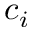<formula> <loc_0><loc_0><loc_500><loc_500>c _ { i }</formula> 